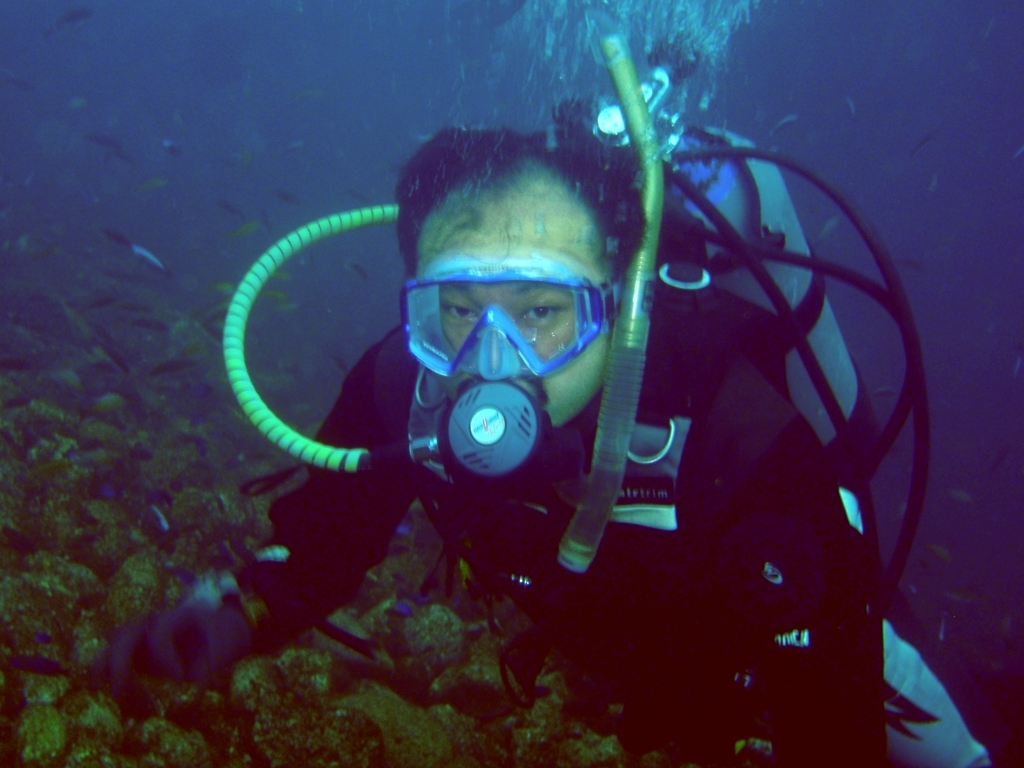Can you tell me more about the environment where this diving activity is taking place? This diving activity seems to be taking place in a natural underwater setting, possibly in an ocean or sea. The visibility is moderate, indicating either a significant depth or particulate matter in the water. The surrounding marine flora suggests a diverse ecosystem, and the diver seems to be observing or interacting with it. How does the underwater environment affect photography? Underwater photography is affected by factors like water clarity, light absorption, and particulate matter. Colors can appear different due to the wavelength absorption of water; red and orange light are absorbed quickly, leaving blue and green tones more prominent. Artificial lighting is often necessary to reveal the true colors and details. Additionally, the water magnifies images, and moving subjects coupled with water currents can challenge the photographer's stability and composition. 